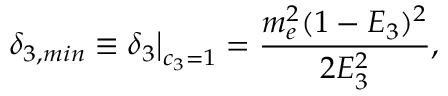<formula> <loc_0><loc_0><loc_500><loc_500>\delta _ { 3 , \min } \equiv \delta _ { 3 } \right | _ { c _ { 3 } = 1 } = \frac { m _ { e } ^ { 2 } ( 1 - E _ { 3 } ) ^ { 2 } } { 2 E _ { 3 } ^ { 2 } } ,</formula> 